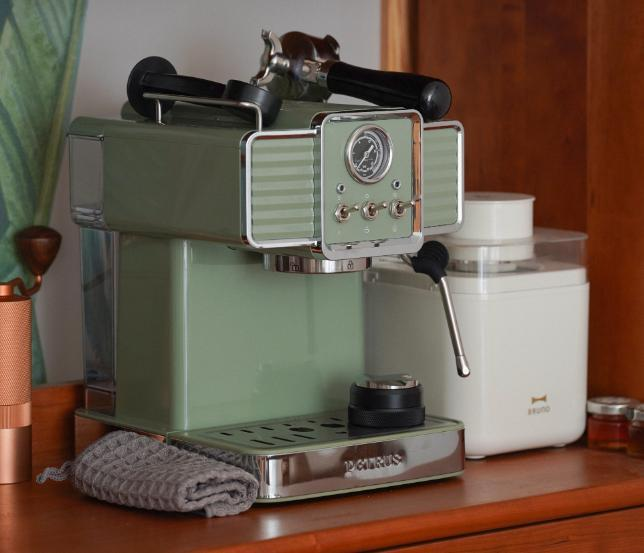图片中有哪些物品 图片中物品包括一台绿色的咖啡机,咖啡机上有两个黑色把手。还有一个白色的储物罐,可能是用来装咖啡豆或糖之类的。旁边有一块灰色的毛巾。咖啡机后面还有一些其他厨房用品,比如木头柜子等。整体看起来像是在一个家庭厨房的角落拍摄的静物照片。 